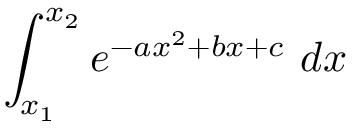<formula> <loc_0><loc_0><loc_500><loc_500>\int _ { x _ { 1 } } ^ { x _ { 2 } } e ^ { - a x ^ { 2 } + b x + c } \ d x</formula> 